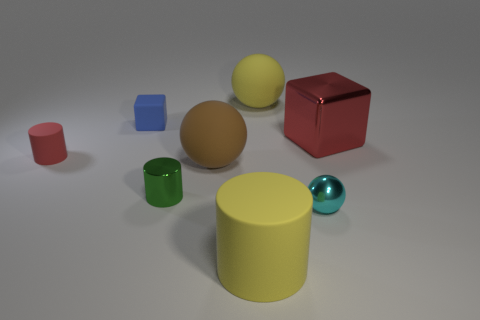What number of other things are there of the same material as the tiny red cylinder
Make the answer very short. 4. Are the big thing that is in front of the tiny green cylinder and the cyan ball made of the same material?
Make the answer very short. No. Are there more matte cylinders in front of the brown rubber ball than green objects in front of the small sphere?
Ensure brevity in your answer.  Yes. What number of objects are either cubes that are to the left of the tiny cyan metal object or tiny red things?
Keep it short and to the point. 2. What shape is the cyan object that is the same material as the large red cube?
Ensure brevity in your answer.  Sphere. There is a matte thing that is both on the right side of the tiny red matte cylinder and left of the big brown object; what color is it?
Make the answer very short. Blue. What number of cubes are either cyan metallic objects or tiny blue matte things?
Ensure brevity in your answer.  1. How many metallic spheres have the same size as the cyan metallic thing?
Keep it short and to the point. 0. There is a matte cylinder in front of the cyan metallic ball; how many large balls are left of it?
Keep it short and to the point. 1. There is a object that is both on the right side of the green shiny cylinder and behind the red metal cube; how big is it?
Your answer should be compact. Large. 